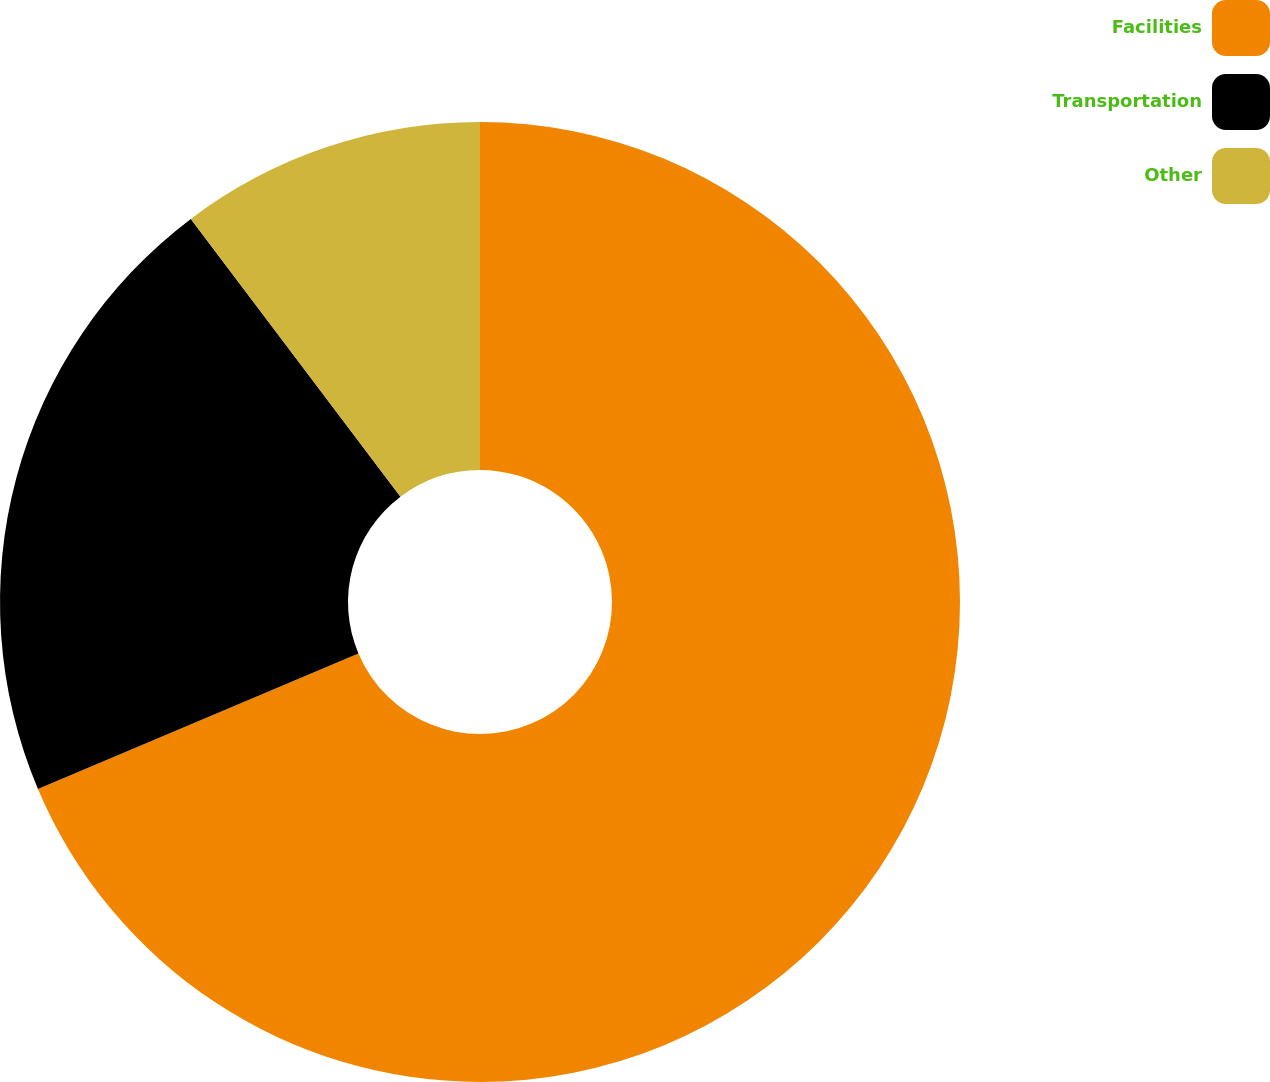Convert chart. <chart><loc_0><loc_0><loc_500><loc_500><pie_chart><fcel>Facilities<fcel>Transportation<fcel>Other<nl><fcel>68.63%<fcel>21.08%<fcel>10.29%<nl></chart> 